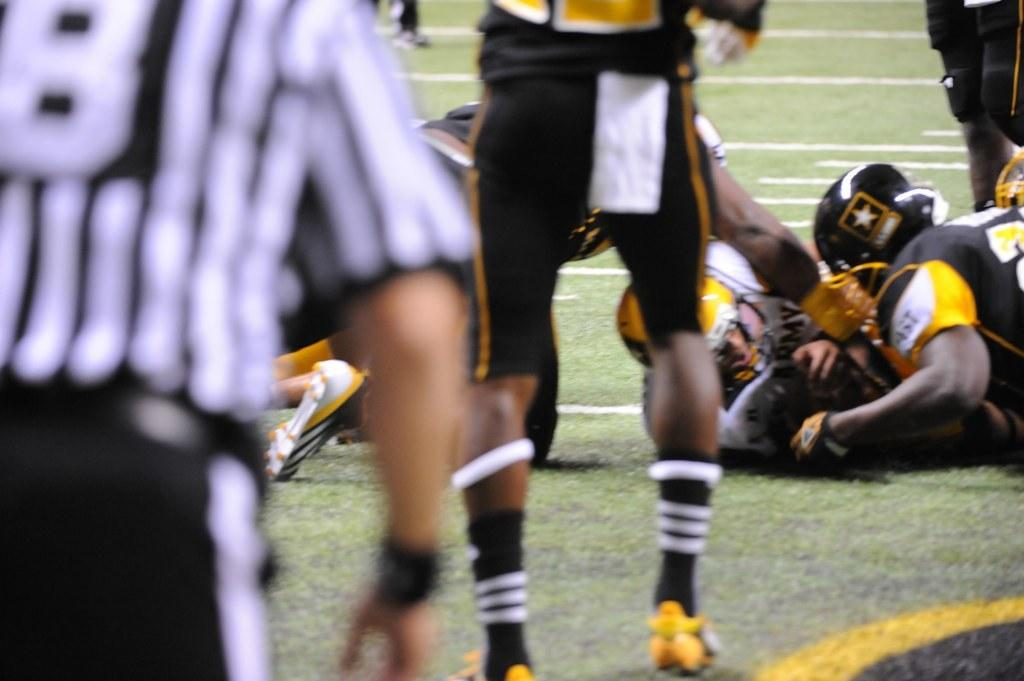What is located on the left side of the image? There is an empire on the left side of the image. What activity is taking place in the middle of the image? People are playing rugby in the middle of the image. What type of sports facility is present in the image? There is a rugby ground in the image. What part of a person can be seen at the top of the image? A person's legs are visible at the top of the image. What type of pump is being used by the rugby players in the image? There is no pump present in the image; the rugby players are playing without any equipment mentioned. What type of ring is visible on the rugby ground in the image? There is no ring visible on the rugby ground in the image; only the rugby players and the field are present. 